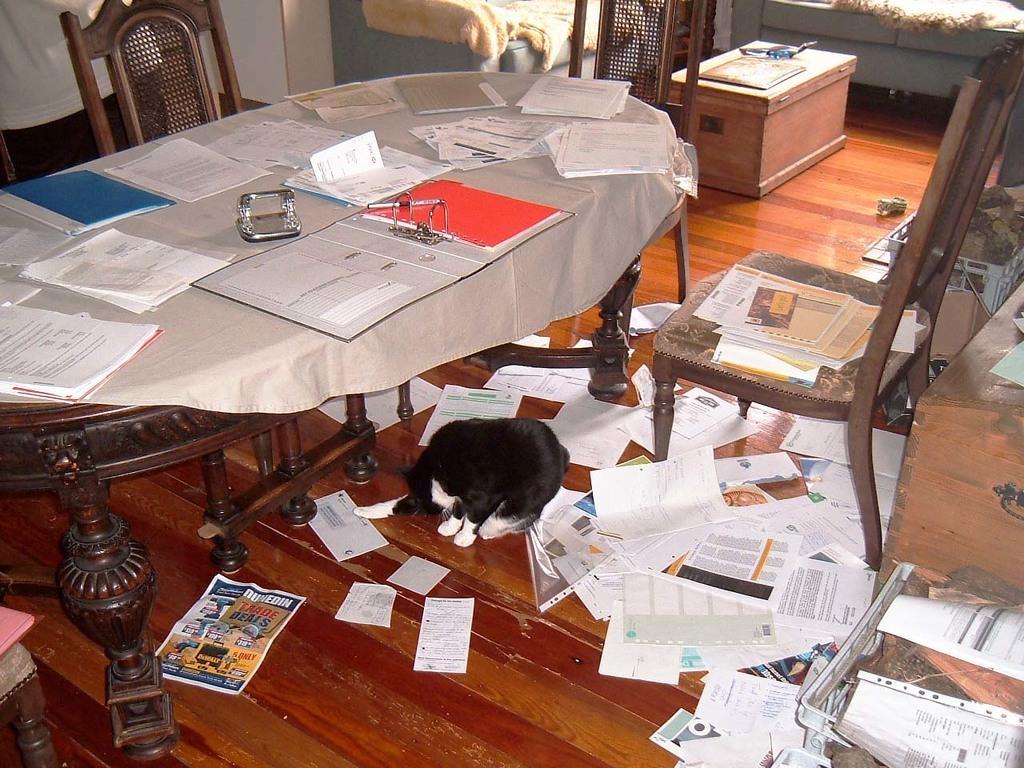Could you give a brief overview of what you see in this image? There is a table. On this table there are files, papers, books , table sheet. Below the table there is a cat. There are three chairs. On the floor there are papers scattered. 